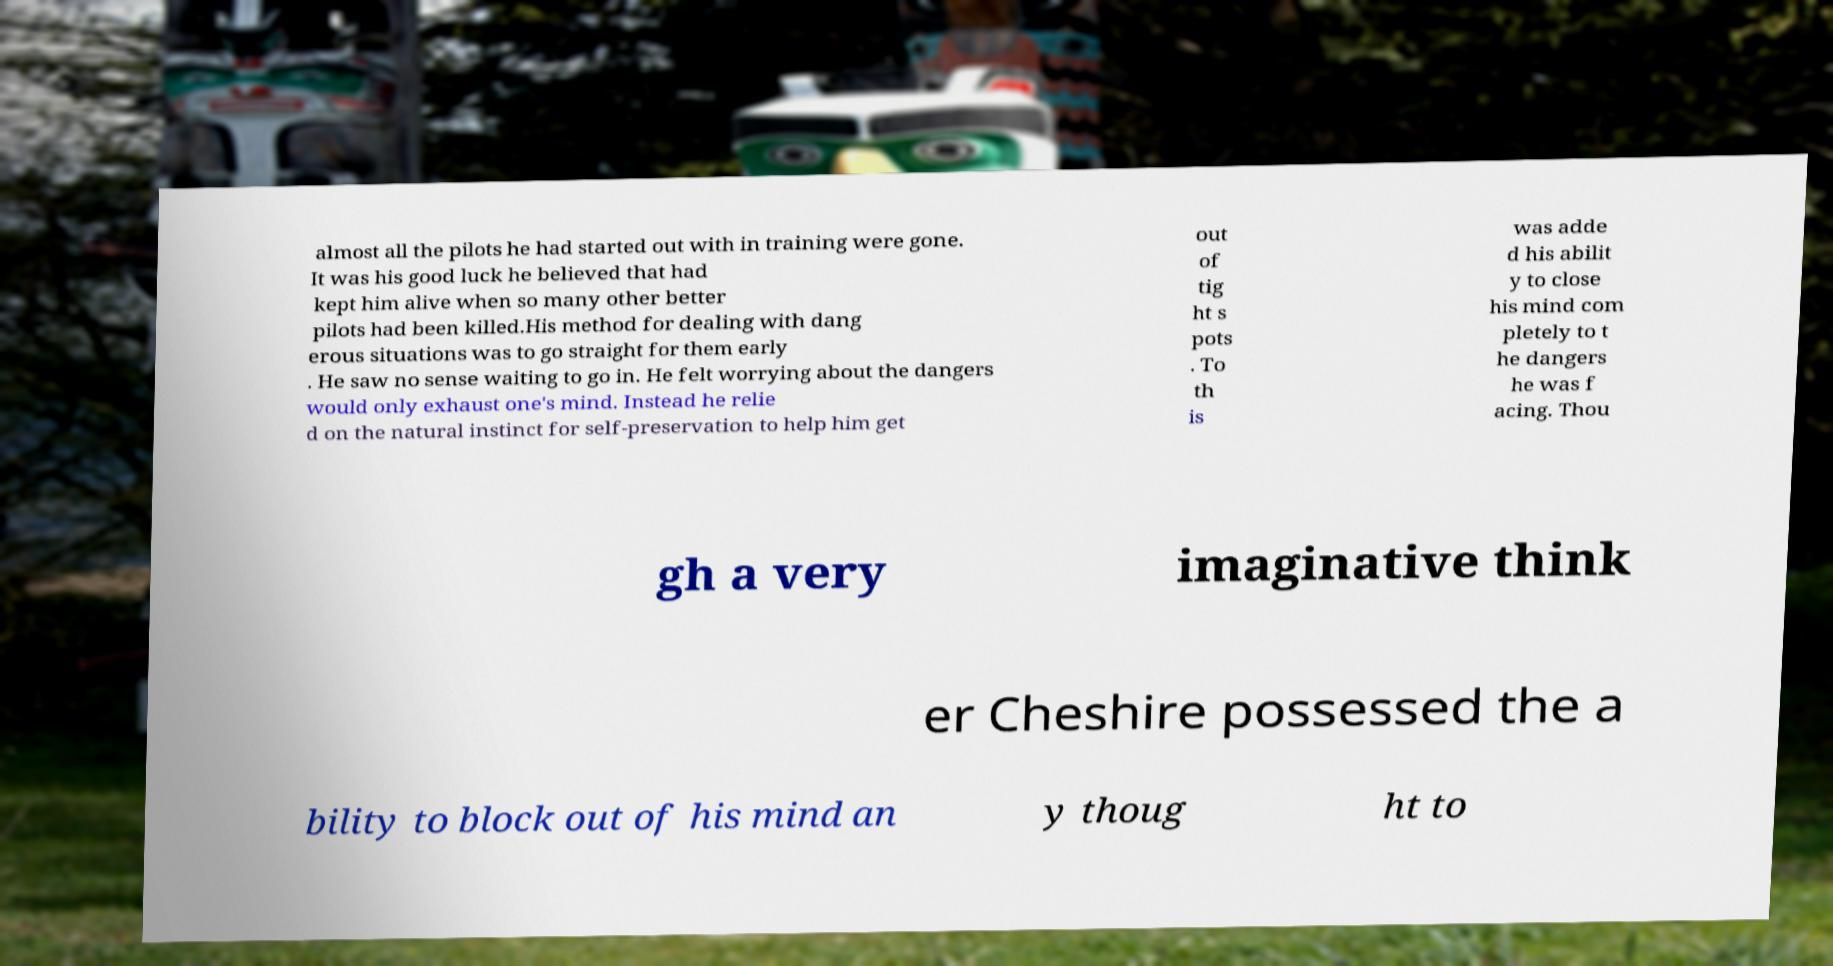There's text embedded in this image that I need extracted. Can you transcribe it verbatim? almost all the pilots he had started out with in training were gone. It was his good luck he believed that had kept him alive when so many other better pilots had been killed.His method for dealing with dang erous situations was to go straight for them early . He saw no sense waiting to go in. He felt worrying about the dangers would only exhaust one's mind. Instead he relie d on the natural instinct for self-preservation to help him get out of tig ht s pots . To th is was adde d his abilit y to close his mind com pletely to t he dangers he was f acing. Thou gh a very imaginative think er Cheshire possessed the a bility to block out of his mind an y thoug ht to 